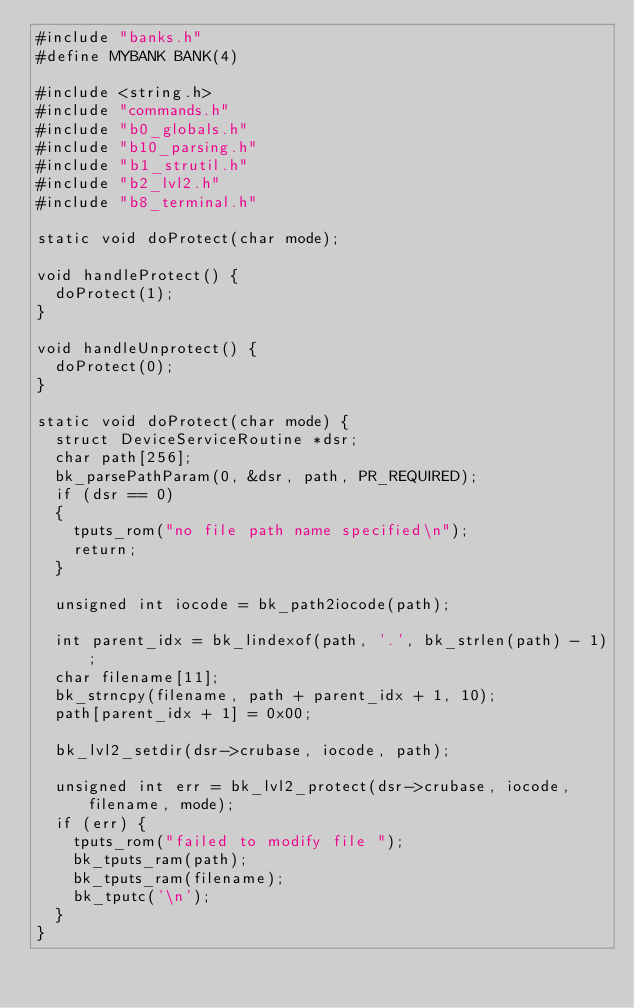<code> <loc_0><loc_0><loc_500><loc_500><_C_>#include "banks.h"
#define MYBANK BANK(4)

#include <string.h>
#include "commands.h"
#include "b0_globals.h"
#include "b10_parsing.h"
#include "b1_strutil.h"
#include "b2_lvl2.h"
#include "b8_terminal.h"

static void doProtect(char mode);

void handleProtect() {
  doProtect(1);
}

void handleUnprotect() {
  doProtect(0);
}

static void doProtect(char mode) {
  struct DeviceServiceRoutine *dsr;
  char path[256];
  bk_parsePathParam(0, &dsr, path, PR_REQUIRED);
  if (dsr == 0)
  {
    tputs_rom("no file path name specified\n");
    return;
  }

  unsigned int iocode = bk_path2iocode(path);

  int parent_idx = bk_lindexof(path, '.', bk_strlen(path) - 1);
  char filename[11];
  bk_strncpy(filename, path + parent_idx + 1, 10);
  path[parent_idx + 1] = 0x00;

  bk_lvl2_setdir(dsr->crubase, iocode, path);

  unsigned int err = bk_lvl2_protect(dsr->crubase, iocode, filename, mode);
  if (err) {
    tputs_rom("failed to modify file ");
    bk_tputs_ram(path);
    bk_tputs_ram(filename);
    bk_tputc('\n');
  }
}
</code> 